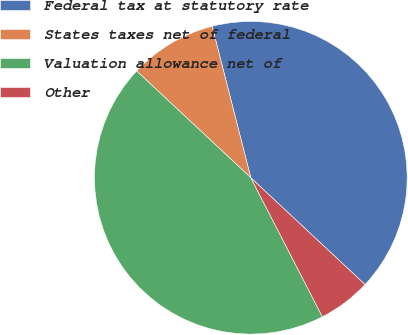Convert chart. <chart><loc_0><loc_0><loc_500><loc_500><pie_chart><fcel>Federal tax at statutory rate<fcel>States taxes net of federal<fcel>Valuation allowance net of<fcel>Other<nl><fcel>40.94%<fcel>9.06%<fcel>44.53%<fcel>5.47%<nl></chart> 